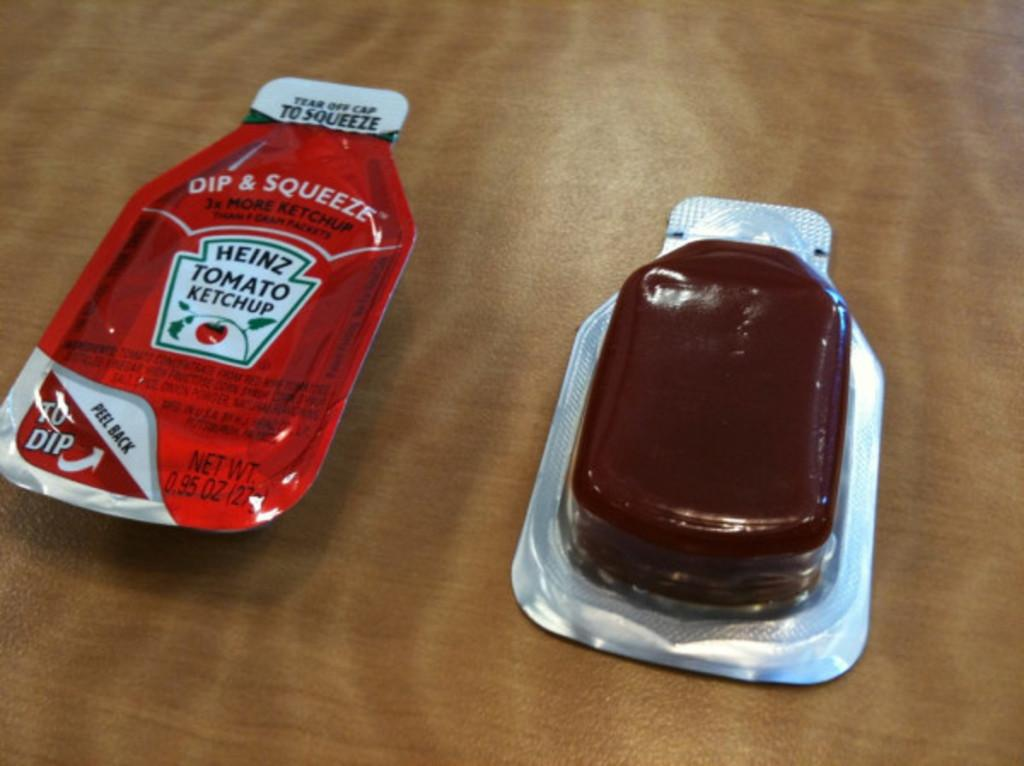<image>
Create a compact narrative representing the image presented. A disposable 0.95 oz packet of Heinz tomato ketchup. 